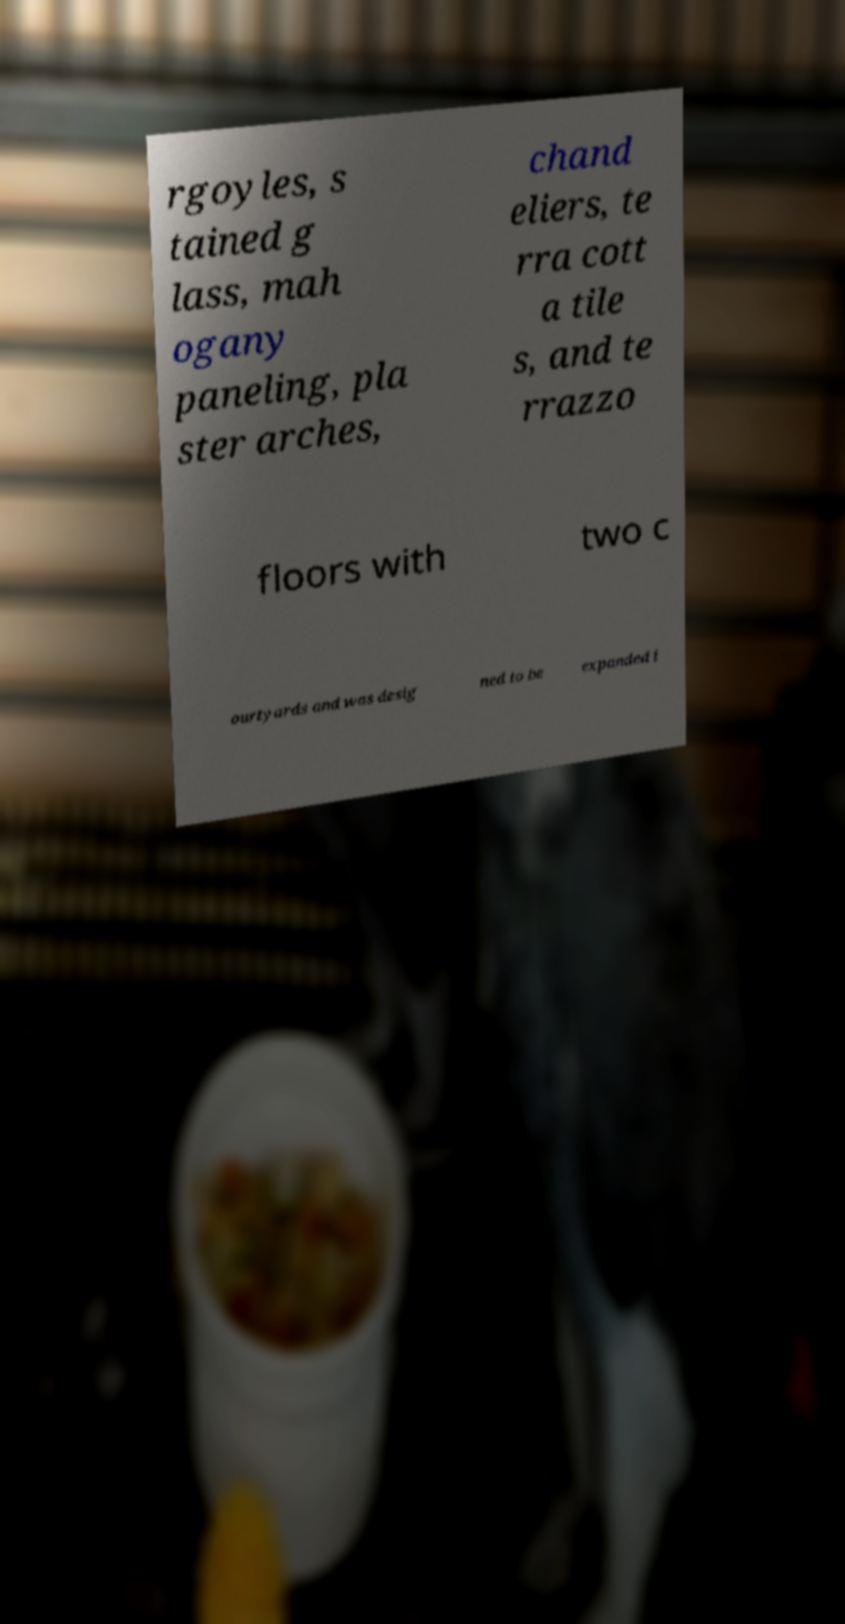There's text embedded in this image that I need extracted. Can you transcribe it verbatim? rgoyles, s tained g lass, mah ogany paneling, pla ster arches, chand eliers, te rra cott a tile s, and te rrazzo floors with two c ourtyards and was desig ned to be expanded i 